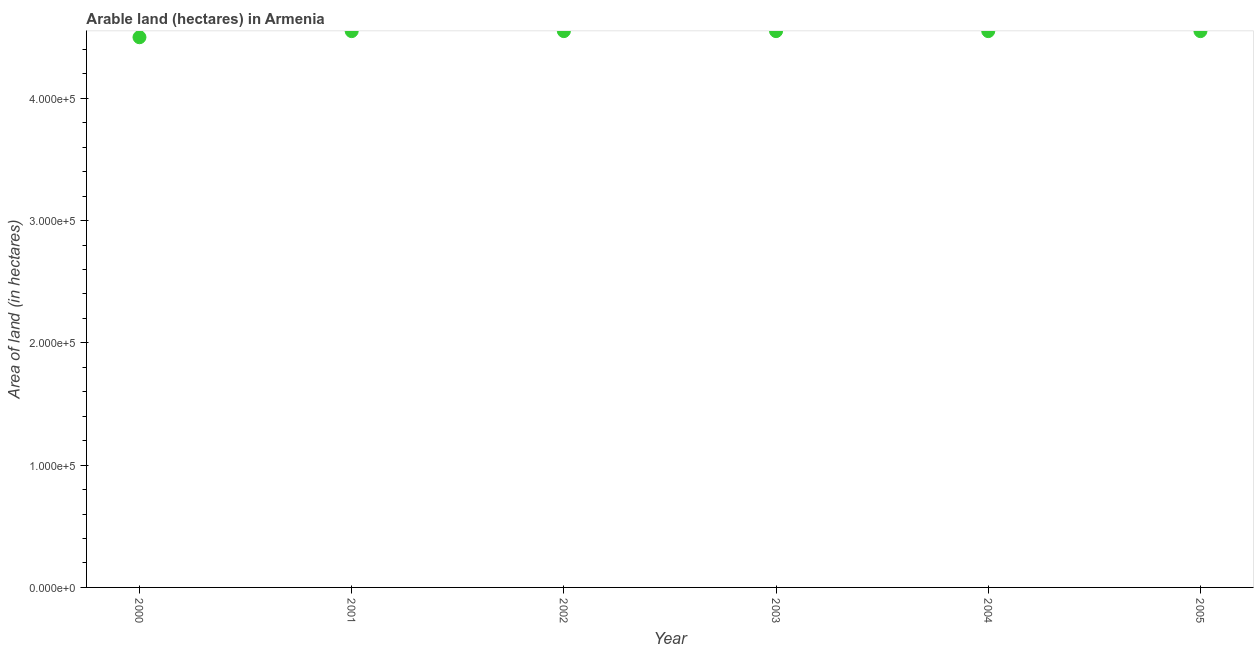What is the area of land in 2005?
Your answer should be very brief. 4.55e+05. Across all years, what is the maximum area of land?
Ensure brevity in your answer.  4.55e+05. Across all years, what is the minimum area of land?
Your answer should be very brief. 4.50e+05. In which year was the area of land minimum?
Offer a very short reply. 2000. What is the sum of the area of land?
Offer a terse response. 2.72e+06. What is the difference between the area of land in 2002 and 2003?
Ensure brevity in your answer.  0. What is the average area of land per year?
Provide a short and direct response. 4.54e+05. What is the median area of land?
Make the answer very short. 4.55e+05. Do a majority of the years between 2005 and 2002 (inclusive) have area of land greater than 400000 hectares?
Ensure brevity in your answer.  Yes. Is the difference between the area of land in 2004 and 2005 greater than the difference between any two years?
Keep it short and to the point. No. What is the difference between the highest and the second highest area of land?
Offer a terse response. 0. Is the sum of the area of land in 2003 and 2005 greater than the maximum area of land across all years?
Offer a very short reply. Yes. What is the difference between the highest and the lowest area of land?
Offer a very short reply. 5000. In how many years, is the area of land greater than the average area of land taken over all years?
Provide a succinct answer. 5. How many dotlines are there?
Make the answer very short. 1. Are the values on the major ticks of Y-axis written in scientific E-notation?
Offer a very short reply. Yes. Does the graph contain any zero values?
Make the answer very short. No. What is the title of the graph?
Ensure brevity in your answer.  Arable land (hectares) in Armenia. What is the label or title of the Y-axis?
Offer a very short reply. Area of land (in hectares). What is the Area of land (in hectares) in 2000?
Your answer should be compact. 4.50e+05. What is the Area of land (in hectares) in 2001?
Your answer should be very brief. 4.55e+05. What is the Area of land (in hectares) in 2002?
Keep it short and to the point. 4.55e+05. What is the Area of land (in hectares) in 2003?
Offer a very short reply. 4.55e+05. What is the Area of land (in hectares) in 2004?
Ensure brevity in your answer.  4.55e+05. What is the Area of land (in hectares) in 2005?
Make the answer very short. 4.55e+05. What is the difference between the Area of land (in hectares) in 2000 and 2001?
Offer a very short reply. -5000. What is the difference between the Area of land (in hectares) in 2000 and 2002?
Your response must be concise. -5000. What is the difference between the Area of land (in hectares) in 2000 and 2003?
Offer a terse response. -5000. What is the difference between the Area of land (in hectares) in 2000 and 2004?
Your response must be concise. -5000. What is the difference between the Area of land (in hectares) in 2000 and 2005?
Provide a short and direct response. -5000. What is the difference between the Area of land (in hectares) in 2001 and 2002?
Your response must be concise. 0. What is the difference between the Area of land (in hectares) in 2001 and 2005?
Make the answer very short. 0. What is the difference between the Area of land (in hectares) in 2002 and 2005?
Provide a short and direct response. 0. What is the difference between the Area of land (in hectares) in 2003 and 2004?
Your answer should be compact. 0. What is the ratio of the Area of land (in hectares) in 2000 to that in 2001?
Provide a succinct answer. 0.99. What is the ratio of the Area of land (in hectares) in 2000 to that in 2003?
Provide a short and direct response. 0.99. What is the ratio of the Area of land (in hectares) in 2000 to that in 2004?
Provide a short and direct response. 0.99. What is the ratio of the Area of land (in hectares) in 2003 to that in 2005?
Offer a terse response. 1. 